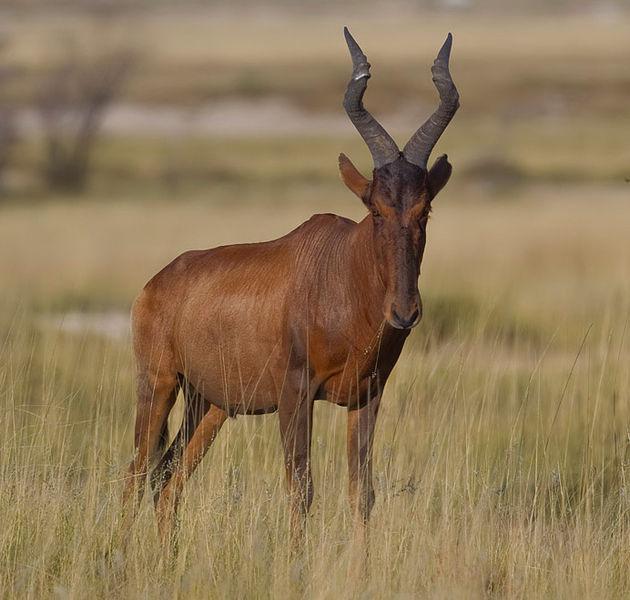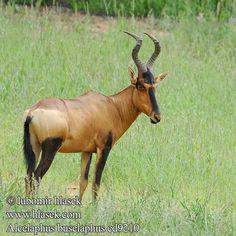The first image is the image on the left, the second image is the image on the right. Considering the images on both sides, is "Each image includes exactly one upright (standing) horned animal with its body in profile." valid? Answer yes or no. Yes. 